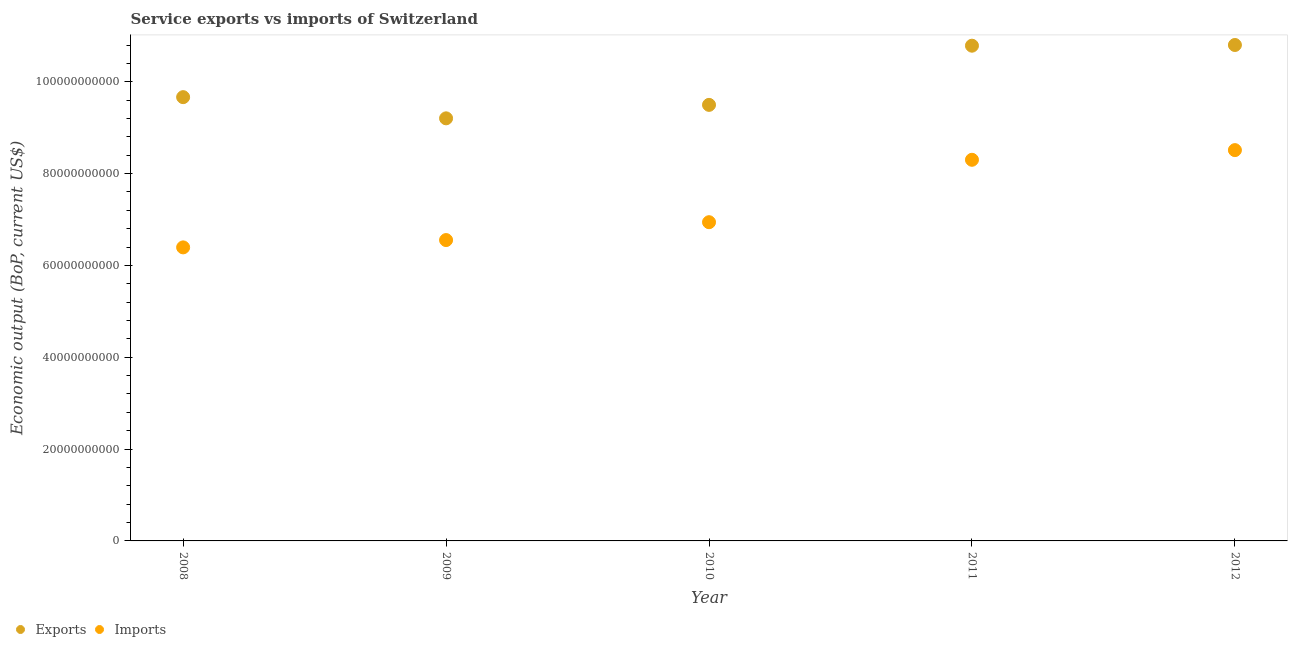What is the amount of service imports in 2011?
Provide a succinct answer. 8.30e+1. Across all years, what is the maximum amount of service imports?
Provide a succinct answer. 8.51e+1. Across all years, what is the minimum amount of service imports?
Make the answer very short. 6.39e+1. What is the total amount of service exports in the graph?
Ensure brevity in your answer.  4.99e+11. What is the difference between the amount of service imports in 2008 and that in 2009?
Your response must be concise. -1.59e+09. What is the difference between the amount of service imports in 2012 and the amount of service exports in 2009?
Give a very brief answer. -6.92e+09. What is the average amount of service imports per year?
Offer a very short reply. 7.34e+1. In the year 2011, what is the difference between the amount of service exports and amount of service imports?
Keep it short and to the point. 2.48e+1. In how many years, is the amount of service exports greater than 92000000000 US$?
Provide a succinct answer. 5. What is the ratio of the amount of service exports in 2009 to that in 2012?
Ensure brevity in your answer.  0.85. Is the difference between the amount of service imports in 2008 and 2011 greater than the difference between the amount of service exports in 2008 and 2011?
Offer a terse response. No. What is the difference between the highest and the second highest amount of service imports?
Make the answer very short. 2.11e+09. What is the difference between the highest and the lowest amount of service imports?
Ensure brevity in your answer.  2.12e+1. In how many years, is the amount of service exports greater than the average amount of service exports taken over all years?
Provide a succinct answer. 2. Is the sum of the amount of service exports in 2009 and 2012 greater than the maximum amount of service imports across all years?
Keep it short and to the point. Yes. Does the amount of service exports monotonically increase over the years?
Keep it short and to the point. No. Is the amount of service imports strictly greater than the amount of service exports over the years?
Offer a terse response. No. Is the amount of service imports strictly less than the amount of service exports over the years?
Ensure brevity in your answer.  Yes. How many dotlines are there?
Offer a terse response. 2. Does the graph contain grids?
Keep it short and to the point. No. Where does the legend appear in the graph?
Offer a terse response. Bottom left. How many legend labels are there?
Provide a short and direct response. 2. What is the title of the graph?
Your response must be concise. Service exports vs imports of Switzerland. Does "Frequency of shipment arrival" appear as one of the legend labels in the graph?
Your response must be concise. No. What is the label or title of the Y-axis?
Offer a terse response. Economic output (BoP, current US$). What is the Economic output (BoP, current US$) of Exports in 2008?
Offer a terse response. 9.66e+1. What is the Economic output (BoP, current US$) in Imports in 2008?
Offer a terse response. 6.39e+1. What is the Economic output (BoP, current US$) of Exports in 2009?
Offer a terse response. 9.20e+1. What is the Economic output (BoP, current US$) of Imports in 2009?
Provide a succinct answer. 6.55e+1. What is the Economic output (BoP, current US$) of Exports in 2010?
Offer a very short reply. 9.50e+1. What is the Economic output (BoP, current US$) of Imports in 2010?
Your response must be concise. 6.94e+1. What is the Economic output (BoP, current US$) of Exports in 2011?
Your answer should be compact. 1.08e+11. What is the Economic output (BoP, current US$) in Imports in 2011?
Your answer should be compact. 8.30e+1. What is the Economic output (BoP, current US$) in Exports in 2012?
Your response must be concise. 1.08e+11. What is the Economic output (BoP, current US$) in Imports in 2012?
Make the answer very short. 8.51e+1. Across all years, what is the maximum Economic output (BoP, current US$) in Exports?
Keep it short and to the point. 1.08e+11. Across all years, what is the maximum Economic output (BoP, current US$) of Imports?
Ensure brevity in your answer.  8.51e+1. Across all years, what is the minimum Economic output (BoP, current US$) of Exports?
Offer a terse response. 9.20e+1. Across all years, what is the minimum Economic output (BoP, current US$) in Imports?
Offer a terse response. 6.39e+1. What is the total Economic output (BoP, current US$) of Exports in the graph?
Your answer should be very brief. 4.99e+11. What is the total Economic output (BoP, current US$) of Imports in the graph?
Make the answer very short. 3.67e+11. What is the difference between the Economic output (BoP, current US$) in Exports in 2008 and that in 2009?
Keep it short and to the point. 4.61e+09. What is the difference between the Economic output (BoP, current US$) in Imports in 2008 and that in 2009?
Your response must be concise. -1.59e+09. What is the difference between the Economic output (BoP, current US$) of Exports in 2008 and that in 2010?
Provide a short and direct response. 1.68e+09. What is the difference between the Economic output (BoP, current US$) of Imports in 2008 and that in 2010?
Your answer should be very brief. -5.48e+09. What is the difference between the Economic output (BoP, current US$) in Exports in 2008 and that in 2011?
Provide a succinct answer. -1.12e+1. What is the difference between the Economic output (BoP, current US$) in Imports in 2008 and that in 2011?
Give a very brief answer. -1.91e+1. What is the difference between the Economic output (BoP, current US$) in Exports in 2008 and that in 2012?
Offer a terse response. -1.14e+1. What is the difference between the Economic output (BoP, current US$) of Imports in 2008 and that in 2012?
Offer a terse response. -2.12e+1. What is the difference between the Economic output (BoP, current US$) in Exports in 2009 and that in 2010?
Your answer should be compact. -2.93e+09. What is the difference between the Economic output (BoP, current US$) in Imports in 2009 and that in 2010?
Make the answer very short. -3.89e+09. What is the difference between the Economic output (BoP, current US$) in Exports in 2009 and that in 2011?
Provide a short and direct response. -1.58e+1. What is the difference between the Economic output (BoP, current US$) in Imports in 2009 and that in 2011?
Provide a short and direct response. -1.75e+1. What is the difference between the Economic output (BoP, current US$) of Exports in 2009 and that in 2012?
Make the answer very short. -1.60e+1. What is the difference between the Economic output (BoP, current US$) in Imports in 2009 and that in 2012?
Ensure brevity in your answer.  -1.96e+1. What is the difference between the Economic output (BoP, current US$) in Exports in 2010 and that in 2011?
Ensure brevity in your answer.  -1.29e+1. What is the difference between the Economic output (BoP, current US$) in Imports in 2010 and that in 2011?
Make the answer very short. -1.36e+1. What is the difference between the Economic output (BoP, current US$) in Exports in 2010 and that in 2012?
Provide a succinct answer. -1.30e+1. What is the difference between the Economic output (BoP, current US$) in Imports in 2010 and that in 2012?
Offer a terse response. -1.57e+1. What is the difference between the Economic output (BoP, current US$) in Exports in 2011 and that in 2012?
Give a very brief answer. -1.53e+08. What is the difference between the Economic output (BoP, current US$) of Imports in 2011 and that in 2012?
Keep it short and to the point. -2.11e+09. What is the difference between the Economic output (BoP, current US$) in Exports in 2008 and the Economic output (BoP, current US$) in Imports in 2009?
Your answer should be compact. 3.11e+1. What is the difference between the Economic output (BoP, current US$) in Exports in 2008 and the Economic output (BoP, current US$) in Imports in 2010?
Give a very brief answer. 2.72e+1. What is the difference between the Economic output (BoP, current US$) of Exports in 2008 and the Economic output (BoP, current US$) of Imports in 2011?
Give a very brief answer. 1.36e+1. What is the difference between the Economic output (BoP, current US$) of Exports in 2008 and the Economic output (BoP, current US$) of Imports in 2012?
Make the answer very short. 1.15e+1. What is the difference between the Economic output (BoP, current US$) of Exports in 2009 and the Economic output (BoP, current US$) of Imports in 2010?
Offer a terse response. 2.26e+1. What is the difference between the Economic output (BoP, current US$) in Exports in 2009 and the Economic output (BoP, current US$) in Imports in 2011?
Give a very brief answer. 9.03e+09. What is the difference between the Economic output (BoP, current US$) of Exports in 2009 and the Economic output (BoP, current US$) of Imports in 2012?
Provide a short and direct response. 6.92e+09. What is the difference between the Economic output (BoP, current US$) of Exports in 2010 and the Economic output (BoP, current US$) of Imports in 2011?
Make the answer very short. 1.20e+1. What is the difference between the Economic output (BoP, current US$) in Exports in 2010 and the Economic output (BoP, current US$) in Imports in 2012?
Give a very brief answer. 9.85e+09. What is the difference between the Economic output (BoP, current US$) of Exports in 2011 and the Economic output (BoP, current US$) of Imports in 2012?
Offer a terse response. 2.27e+1. What is the average Economic output (BoP, current US$) in Exports per year?
Your response must be concise. 9.99e+1. What is the average Economic output (BoP, current US$) in Imports per year?
Ensure brevity in your answer.  7.34e+1. In the year 2008, what is the difference between the Economic output (BoP, current US$) in Exports and Economic output (BoP, current US$) in Imports?
Provide a succinct answer. 3.27e+1. In the year 2009, what is the difference between the Economic output (BoP, current US$) of Exports and Economic output (BoP, current US$) of Imports?
Ensure brevity in your answer.  2.65e+1. In the year 2010, what is the difference between the Economic output (BoP, current US$) of Exports and Economic output (BoP, current US$) of Imports?
Provide a short and direct response. 2.56e+1. In the year 2011, what is the difference between the Economic output (BoP, current US$) of Exports and Economic output (BoP, current US$) of Imports?
Offer a terse response. 2.48e+1. In the year 2012, what is the difference between the Economic output (BoP, current US$) in Exports and Economic output (BoP, current US$) in Imports?
Offer a very short reply. 2.29e+1. What is the ratio of the Economic output (BoP, current US$) of Exports in 2008 to that in 2009?
Provide a succinct answer. 1.05. What is the ratio of the Economic output (BoP, current US$) in Imports in 2008 to that in 2009?
Keep it short and to the point. 0.98. What is the ratio of the Economic output (BoP, current US$) in Exports in 2008 to that in 2010?
Ensure brevity in your answer.  1.02. What is the ratio of the Economic output (BoP, current US$) of Imports in 2008 to that in 2010?
Your answer should be very brief. 0.92. What is the ratio of the Economic output (BoP, current US$) in Exports in 2008 to that in 2011?
Keep it short and to the point. 0.9. What is the ratio of the Economic output (BoP, current US$) of Imports in 2008 to that in 2011?
Give a very brief answer. 0.77. What is the ratio of the Economic output (BoP, current US$) in Exports in 2008 to that in 2012?
Offer a terse response. 0.89. What is the ratio of the Economic output (BoP, current US$) of Imports in 2008 to that in 2012?
Your answer should be compact. 0.75. What is the ratio of the Economic output (BoP, current US$) of Exports in 2009 to that in 2010?
Provide a short and direct response. 0.97. What is the ratio of the Economic output (BoP, current US$) of Imports in 2009 to that in 2010?
Offer a terse response. 0.94. What is the ratio of the Economic output (BoP, current US$) in Exports in 2009 to that in 2011?
Offer a very short reply. 0.85. What is the ratio of the Economic output (BoP, current US$) of Imports in 2009 to that in 2011?
Your answer should be compact. 0.79. What is the ratio of the Economic output (BoP, current US$) of Exports in 2009 to that in 2012?
Provide a succinct answer. 0.85. What is the ratio of the Economic output (BoP, current US$) in Imports in 2009 to that in 2012?
Provide a short and direct response. 0.77. What is the ratio of the Economic output (BoP, current US$) in Exports in 2010 to that in 2011?
Give a very brief answer. 0.88. What is the ratio of the Economic output (BoP, current US$) of Imports in 2010 to that in 2011?
Offer a very short reply. 0.84. What is the ratio of the Economic output (BoP, current US$) of Exports in 2010 to that in 2012?
Ensure brevity in your answer.  0.88. What is the ratio of the Economic output (BoP, current US$) in Imports in 2010 to that in 2012?
Provide a short and direct response. 0.82. What is the ratio of the Economic output (BoP, current US$) of Exports in 2011 to that in 2012?
Offer a terse response. 1. What is the ratio of the Economic output (BoP, current US$) of Imports in 2011 to that in 2012?
Give a very brief answer. 0.98. What is the difference between the highest and the second highest Economic output (BoP, current US$) in Exports?
Provide a succinct answer. 1.53e+08. What is the difference between the highest and the second highest Economic output (BoP, current US$) in Imports?
Provide a succinct answer. 2.11e+09. What is the difference between the highest and the lowest Economic output (BoP, current US$) of Exports?
Ensure brevity in your answer.  1.60e+1. What is the difference between the highest and the lowest Economic output (BoP, current US$) in Imports?
Your answer should be compact. 2.12e+1. 